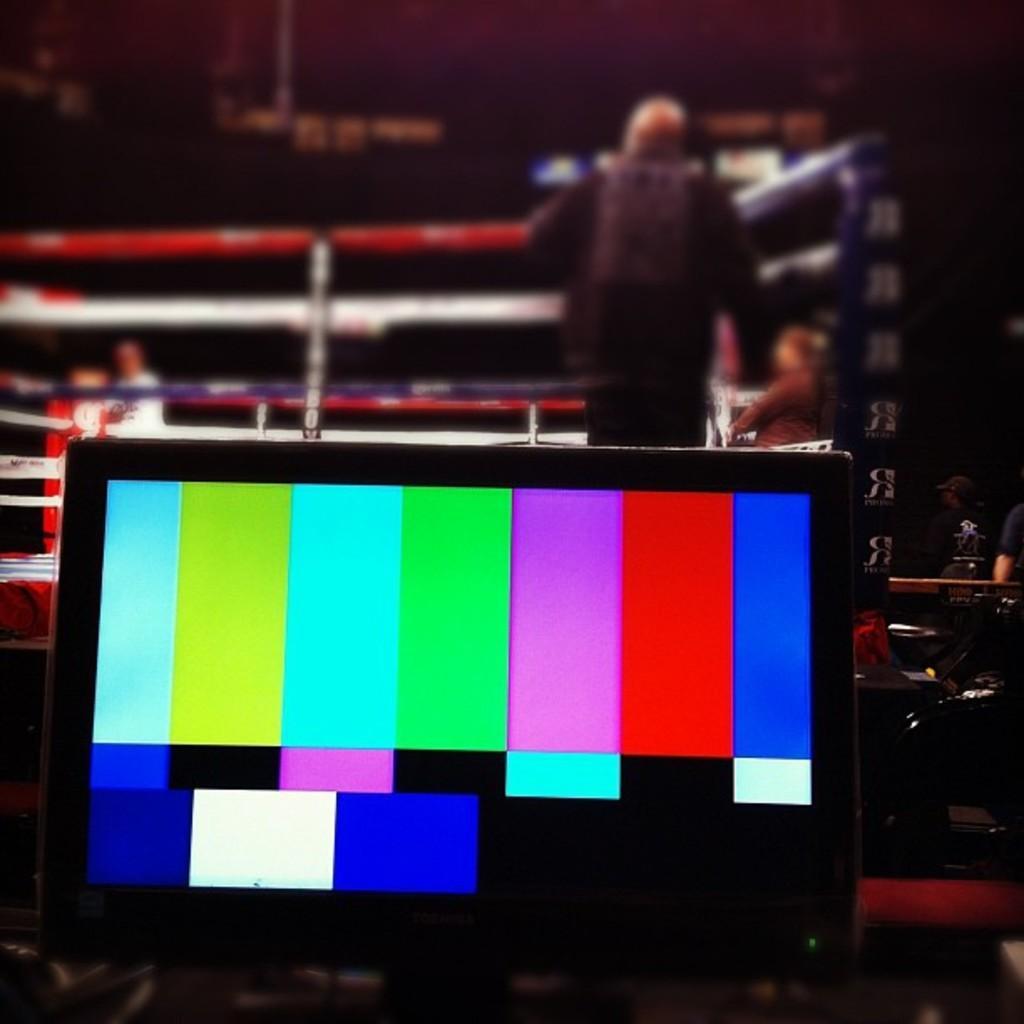Can you describe this image briefly? As we can see in the image there is a screen and few people standing here and there. The image is little dark. 